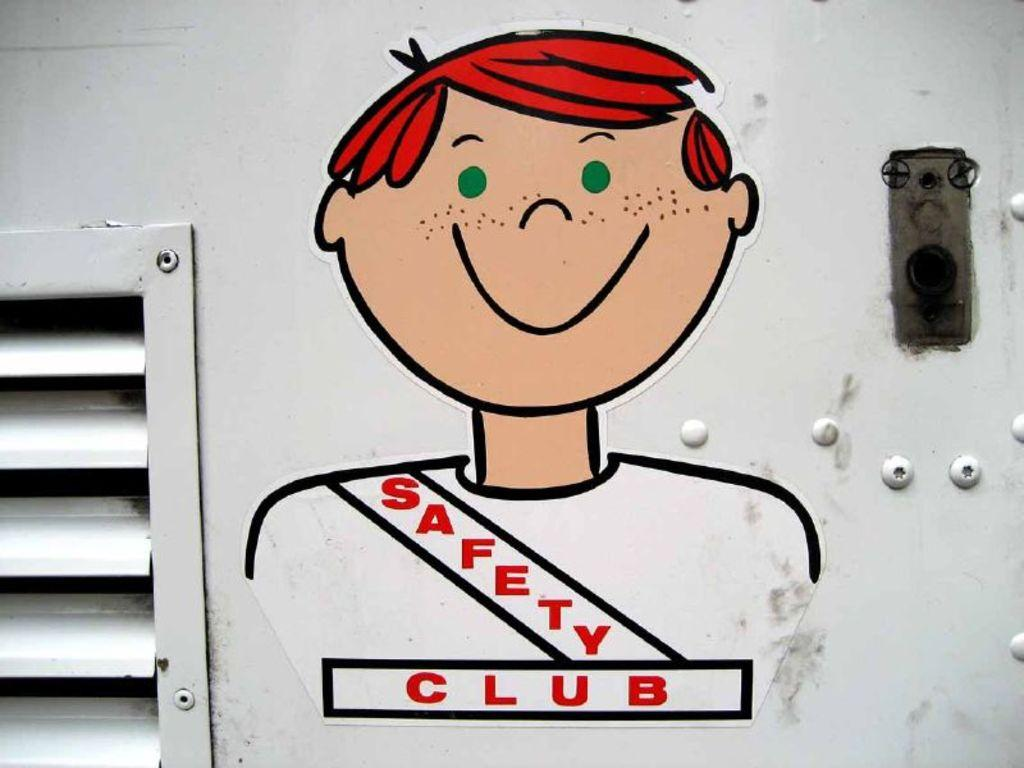What is present on the wall in the image? There is a window and a painting on the wall in the image. Can you describe the window? The window is white in color. What is depicted in the painting? The painting depicts a boy. What is the title or label of the painting? The painting is labeled as "safety club." Where is the toy located in the image? There is no toy present in the image. What type of root can be seen growing near the wall in the image? There are no roots visible in the image; it only shows a wall with a window and a painting. 